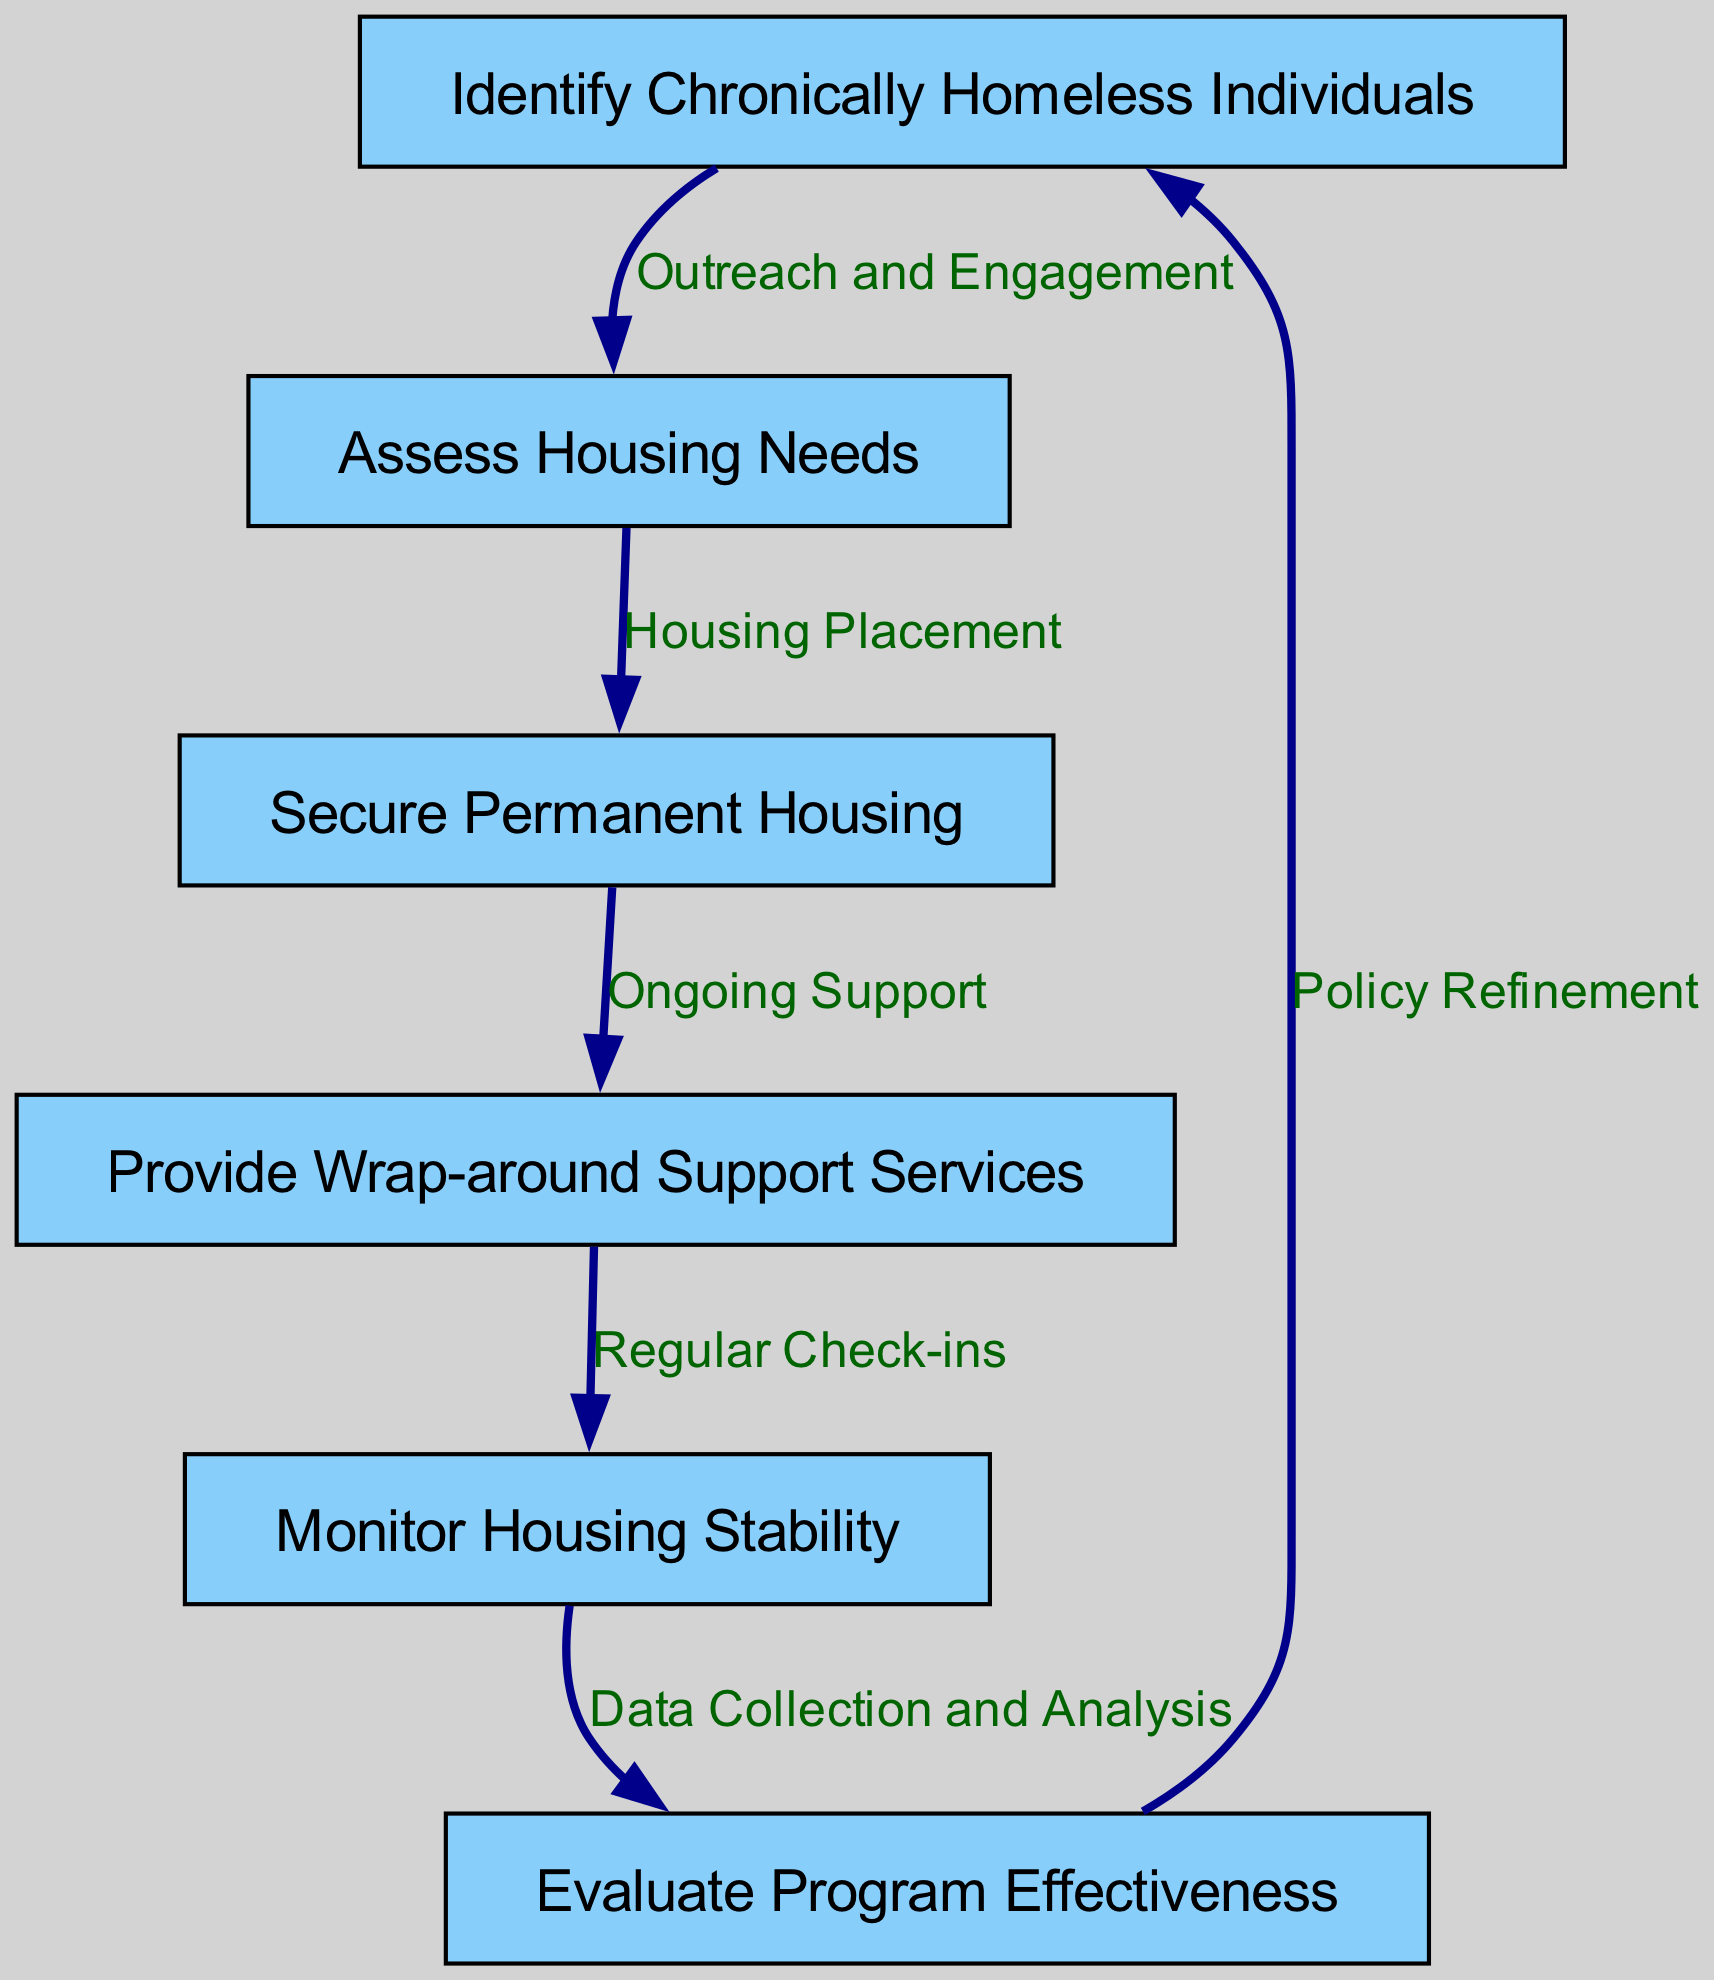What is the first node in the clinical pathway? The first node in the clinical pathway is "Identify Chronically Homeless Individuals," as indicated at the top of the flow.
Answer: Identify Chronically Homeless Individuals How many nodes are there in total? There are six nodes illustrated in the diagram that represent different steps in the clinical pathway.
Answer: 6 What is the relationship between nodes 2 and 3? The relationship between nodes 2 and 3 is labeled "Housing Placement," indicating the action taken to move from assessing needs to securing housing.
Answer: Housing Placement What type of support is provided after securing permanent housing? After securing permanent housing, the provided support is "Wrap-around Support Services" as indicated by the connection from node 3 to node 4.
Answer: Wrap-around Support Services What feedback mechanism exists in the pathway? The feedback mechanism exists in the path going from "Evaluate Program Effectiveness" back to "Identify Chronically Homeless Individuals" for "Policy Refinement," suggesting continuous improvement based on evaluation results.
Answer: Policy Refinement What is the last step in the clinical pathway? The last step in the clinical pathway is "Evaluate Program Effectiveness," which concludes the process of ensuring the program meets its goals and adapting policies accordingly.
Answer: Evaluate Program Effectiveness What action occurs after monitoring housing stability? The action that occurs after monitoring housing stability is "Evaluate Program Effectiveness," indicating that monitoring leads to assessing the overall effectiveness of the program.
Answer: Evaluate Program Effectiveness What two nodes are connected by "Regular Check-ins"? "Regular Check-ins" connects the nodes "Provide Wrap-around Support Services" and "Monitor Housing Stability," indicating the importance of checking in after services are delivered.
Answer: Provide Wrap-around Support Services and Monitor Housing Stability What is the ultimate goal of this clinical pathway? The ultimate goal of this clinical pathway is to secure housing and provide the necessary support to ensure stability, contributing to the overarching aim of addressing homelessness effectively.
Answer: Secure Permanent Housing and Provide Wrap-around Support Services 